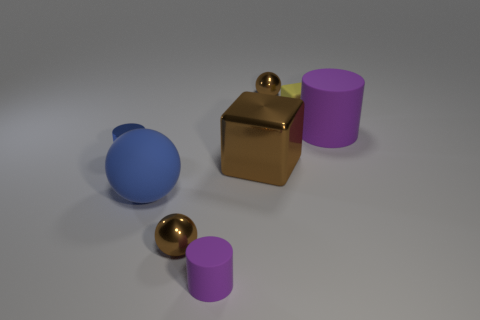Add 1 big blue things. How many objects exist? 9 Subtract all cubes. How many objects are left? 6 Subtract 1 brown balls. How many objects are left? 7 Subtract all small metal things. Subtract all cyan cubes. How many objects are left? 5 Add 6 big brown cubes. How many big brown cubes are left? 7 Add 2 large matte cylinders. How many large matte cylinders exist? 3 